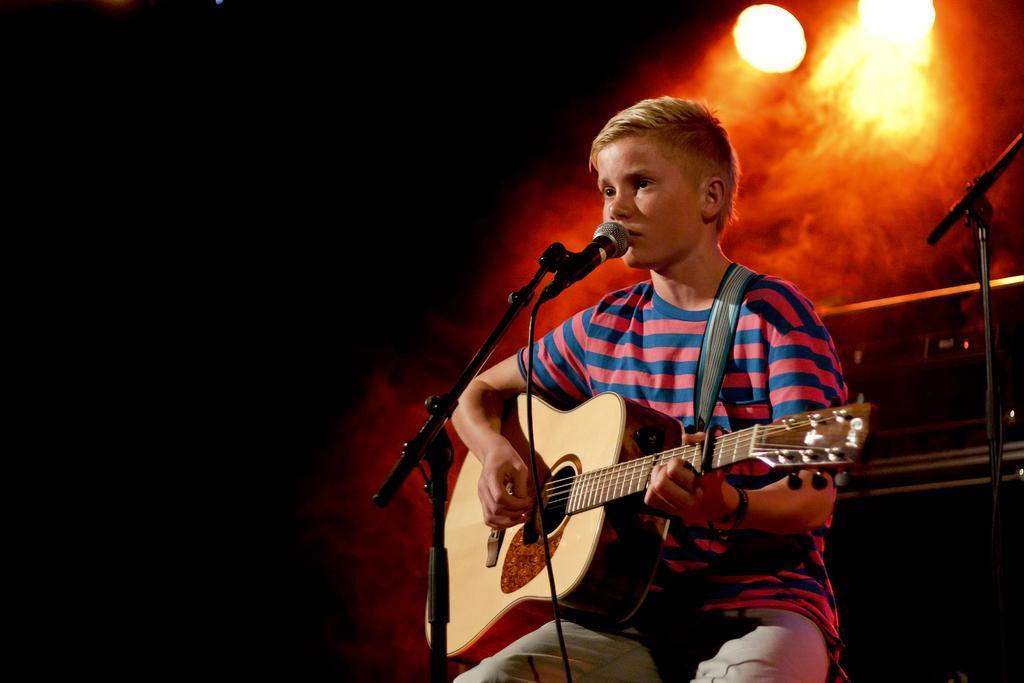Could you give a brief overview of what you see in this image? In this picture there is a boy who is sitting at the right side of the image, by holding the guitar in his hands and there is a mic in front of him, there are spotlights above the area of the image. 